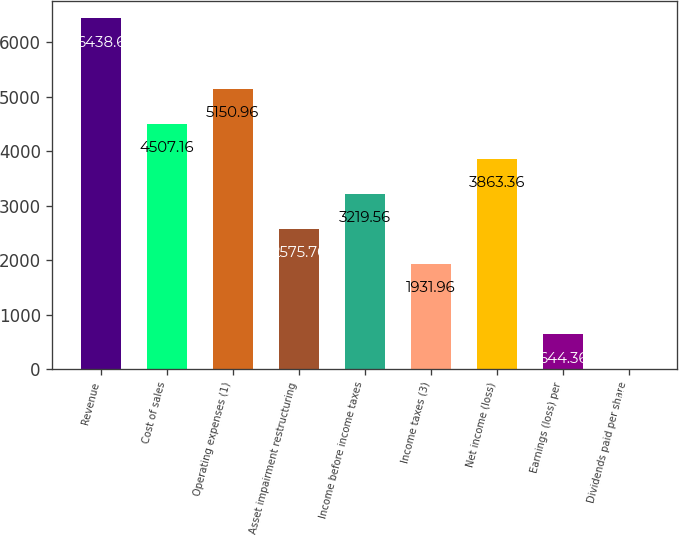Convert chart. <chart><loc_0><loc_0><loc_500><loc_500><bar_chart><fcel>Revenue<fcel>Cost of sales<fcel>Operating expenses (1)<fcel>Asset impairment restructuring<fcel>Income before income taxes<fcel>Income taxes (3)<fcel>Net income (loss)<fcel>Earnings (loss) per<fcel>Dividends paid per share<nl><fcel>6438.6<fcel>4507.16<fcel>5150.96<fcel>2575.76<fcel>3219.56<fcel>1931.96<fcel>3863.36<fcel>644.36<fcel>0.56<nl></chart> 